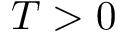Convert formula to latex. <formula><loc_0><loc_0><loc_500><loc_500>T > 0</formula> 